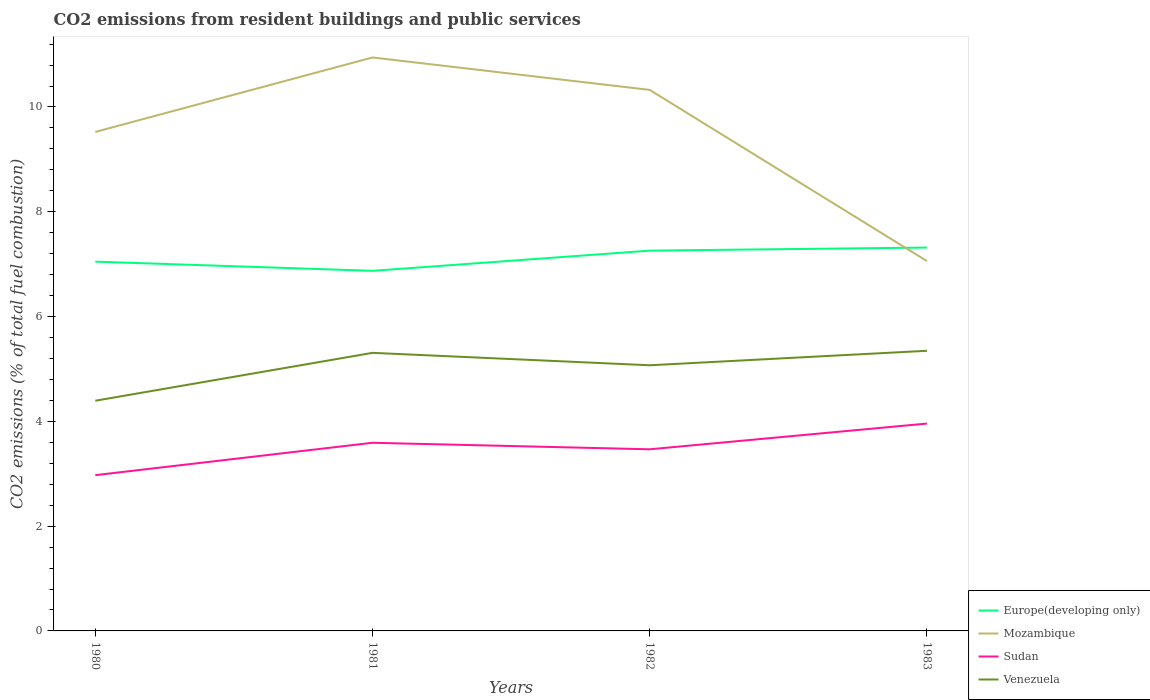Across all years, what is the maximum total CO2 emitted in Venezuela?
Give a very brief answer. 4.39. What is the total total CO2 emitted in Europe(developing only) in the graph?
Your response must be concise. -0.21. What is the difference between the highest and the second highest total CO2 emitted in Mozambique?
Provide a short and direct response. 3.89. Is the total CO2 emitted in Venezuela strictly greater than the total CO2 emitted in Sudan over the years?
Your answer should be compact. No. How many years are there in the graph?
Provide a succinct answer. 4. What is the difference between two consecutive major ticks on the Y-axis?
Provide a short and direct response. 2. Does the graph contain any zero values?
Your response must be concise. No. Where does the legend appear in the graph?
Offer a terse response. Bottom right. How many legend labels are there?
Offer a very short reply. 4. How are the legend labels stacked?
Keep it short and to the point. Vertical. What is the title of the graph?
Keep it short and to the point. CO2 emissions from resident buildings and public services. Does "Sierra Leone" appear as one of the legend labels in the graph?
Give a very brief answer. No. What is the label or title of the Y-axis?
Your answer should be very brief. CO2 emissions (% of total fuel combustion). What is the CO2 emissions (% of total fuel combustion) in Europe(developing only) in 1980?
Make the answer very short. 7.05. What is the CO2 emissions (% of total fuel combustion) of Mozambique in 1980?
Ensure brevity in your answer.  9.52. What is the CO2 emissions (% of total fuel combustion) of Sudan in 1980?
Offer a very short reply. 2.97. What is the CO2 emissions (% of total fuel combustion) of Venezuela in 1980?
Offer a terse response. 4.39. What is the CO2 emissions (% of total fuel combustion) of Europe(developing only) in 1981?
Offer a terse response. 6.87. What is the CO2 emissions (% of total fuel combustion) in Mozambique in 1981?
Give a very brief answer. 10.95. What is the CO2 emissions (% of total fuel combustion) in Sudan in 1981?
Provide a short and direct response. 3.59. What is the CO2 emissions (% of total fuel combustion) in Venezuela in 1981?
Offer a very short reply. 5.31. What is the CO2 emissions (% of total fuel combustion) of Europe(developing only) in 1982?
Provide a short and direct response. 7.26. What is the CO2 emissions (% of total fuel combustion) of Mozambique in 1982?
Your response must be concise. 10.33. What is the CO2 emissions (% of total fuel combustion) of Sudan in 1982?
Your response must be concise. 3.47. What is the CO2 emissions (% of total fuel combustion) of Venezuela in 1982?
Offer a very short reply. 5.07. What is the CO2 emissions (% of total fuel combustion) in Europe(developing only) in 1983?
Your answer should be compact. 7.32. What is the CO2 emissions (% of total fuel combustion) in Mozambique in 1983?
Provide a succinct answer. 7.06. What is the CO2 emissions (% of total fuel combustion) of Sudan in 1983?
Your response must be concise. 3.96. What is the CO2 emissions (% of total fuel combustion) in Venezuela in 1983?
Offer a terse response. 5.35. Across all years, what is the maximum CO2 emissions (% of total fuel combustion) in Europe(developing only)?
Keep it short and to the point. 7.32. Across all years, what is the maximum CO2 emissions (% of total fuel combustion) of Mozambique?
Give a very brief answer. 10.95. Across all years, what is the maximum CO2 emissions (% of total fuel combustion) of Sudan?
Give a very brief answer. 3.96. Across all years, what is the maximum CO2 emissions (% of total fuel combustion) of Venezuela?
Give a very brief answer. 5.35. Across all years, what is the minimum CO2 emissions (% of total fuel combustion) of Europe(developing only)?
Keep it short and to the point. 6.87. Across all years, what is the minimum CO2 emissions (% of total fuel combustion) in Mozambique?
Your response must be concise. 7.06. Across all years, what is the minimum CO2 emissions (% of total fuel combustion) in Sudan?
Offer a very short reply. 2.97. Across all years, what is the minimum CO2 emissions (% of total fuel combustion) in Venezuela?
Your answer should be compact. 4.39. What is the total CO2 emissions (% of total fuel combustion) of Europe(developing only) in the graph?
Provide a succinct answer. 28.5. What is the total CO2 emissions (% of total fuel combustion) of Mozambique in the graph?
Your answer should be very brief. 37.85. What is the total CO2 emissions (% of total fuel combustion) of Sudan in the graph?
Your answer should be compact. 13.99. What is the total CO2 emissions (% of total fuel combustion) in Venezuela in the graph?
Make the answer very short. 20.12. What is the difference between the CO2 emissions (% of total fuel combustion) in Europe(developing only) in 1980 and that in 1981?
Offer a very short reply. 0.18. What is the difference between the CO2 emissions (% of total fuel combustion) in Mozambique in 1980 and that in 1981?
Ensure brevity in your answer.  -1.42. What is the difference between the CO2 emissions (% of total fuel combustion) in Sudan in 1980 and that in 1981?
Offer a terse response. -0.62. What is the difference between the CO2 emissions (% of total fuel combustion) of Venezuela in 1980 and that in 1981?
Ensure brevity in your answer.  -0.91. What is the difference between the CO2 emissions (% of total fuel combustion) of Europe(developing only) in 1980 and that in 1982?
Your answer should be compact. -0.21. What is the difference between the CO2 emissions (% of total fuel combustion) in Mozambique in 1980 and that in 1982?
Provide a succinct answer. -0.8. What is the difference between the CO2 emissions (% of total fuel combustion) of Sudan in 1980 and that in 1982?
Make the answer very short. -0.49. What is the difference between the CO2 emissions (% of total fuel combustion) in Venezuela in 1980 and that in 1982?
Ensure brevity in your answer.  -0.68. What is the difference between the CO2 emissions (% of total fuel combustion) in Europe(developing only) in 1980 and that in 1983?
Your answer should be very brief. -0.27. What is the difference between the CO2 emissions (% of total fuel combustion) of Mozambique in 1980 and that in 1983?
Keep it short and to the point. 2.46. What is the difference between the CO2 emissions (% of total fuel combustion) in Sudan in 1980 and that in 1983?
Your answer should be very brief. -0.98. What is the difference between the CO2 emissions (% of total fuel combustion) in Venezuela in 1980 and that in 1983?
Provide a succinct answer. -0.95. What is the difference between the CO2 emissions (% of total fuel combustion) of Europe(developing only) in 1981 and that in 1982?
Provide a succinct answer. -0.39. What is the difference between the CO2 emissions (% of total fuel combustion) in Mozambique in 1981 and that in 1982?
Your answer should be compact. 0.62. What is the difference between the CO2 emissions (% of total fuel combustion) of Sudan in 1981 and that in 1982?
Give a very brief answer. 0.12. What is the difference between the CO2 emissions (% of total fuel combustion) of Venezuela in 1981 and that in 1982?
Your response must be concise. 0.24. What is the difference between the CO2 emissions (% of total fuel combustion) of Europe(developing only) in 1981 and that in 1983?
Keep it short and to the point. -0.44. What is the difference between the CO2 emissions (% of total fuel combustion) in Mozambique in 1981 and that in 1983?
Provide a short and direct response. 3.89. What is the difference between the CO2 emissions (% of total fuel combustion) of Sudan in 1981 and that in 1983?
Provide a succinct answer. -0.37. What is the difference between the CO2 emissions (% of total fuel combustion) of Venezuela in 1981 and that in 1983?
Provide a short and direct response. -0.04. What is the difference between the CO2 emissions (% of total fuel combustion) in Europe(developing only) in 1982 and that in 1983?
Provide a succinct answer. -0.06. What is the difference between the CO2 emissions (% of total fuel combustion) in Mozambique in 1982 and that in 1983?
Your answer should be very brief. 3.27. What is the difference between the CO2 emissions (% of total fuel combustion) in Sudan in 1982 and that in 1983?
Offer a very short reply. -0.49. What is the difference between the CO2 emissions (% of total fuel combustion) of Venezuela in 1982 and that in 1983?
Provide a succinct answer. -0.28. What is the difference between the CO2 emissions (% of total fuel combustion) in Europe(developing only) in 1980 and the CO2 emissions (% of total fuel combustion) in Mozambique in 1981?
Give a very brief answer. -3.9. What is the difference between the CO2 emissions (% of total fuel combustion) in Europe(developing only) in 1980 and the CO2 emissions (% of total fuel combustion) in Sudan in 1981?
Give a very brief answer. 3.46. What is the difference between the CO2 emissions (% of total fuel combustion) of Europe(developing only) in 1980 and the CO2 emissions (% of total fuel combustion) of Venezuela in 1981?
Your response must be concise. 1.74. What is the difference between the CO2 emissions (% of total fuel combustion) in Mozambique in 1980 and the CO2 emissions (% of total fuel combustion) in Sudan in 1981?
Ensure brevity in your answer.  5.93. What is the difference between the CO2 emissions (% of total fuel combustion) in Mozambique in 1980 and the CO2 emissions (% of total fuel combustion) in Venezuela in 1981?
Make the answer very short. 4.22. What is the difference between the CO2 emissions (% of total fuel combustion) in Sudan in 1980 and the CO2 emissions (% of total fuel combustion) in Venezuela in 1981?
Offer a very short reply. -2.33. What is the difference between the CO2 emissions (% of total fuel combustion) of Europe(developing only) in 1980 and the CO2 emissions (% of total fuel combustion) of Mozambique in 1982?
Ensure brevity in your answer.  -3.28. What is the difference between the CO2 emissions (% of total fuel combustion) of Europe(developing only) in 1980 and the CO2 emissions (% of total fuel combustion) of Sudan in 1982?
Your answer should be very brief. 3.58. What is the difference between the CO2 emissions (% of total fuel combustion) of Europe(developing only) in 1980 and the CO2 emissions (% of total fuel combustion) of Venezuela in 1982?
Your answer should be compact. 1.98. What is the difference between the CO2 emissions (% of total fuel combustion) of Mozambique in 1980 and the CO2 emissions (% of total fuel combustion) of Sudan in 1982?
Make the answer very short. 6.06. What is the difference between the CO2 emissions (% of total fuel combustion) in Mozambique in 1980 and the CO2 emissions (% of total fuel combustion) in Venezuela in 1982?
Offer a very short reply. 4.45. What is the difference between the CO2 emissions (% of total fuel combustion) in Sudan in 1980 and the CO2 emissions (% of total fuel combustion) in Venezuela in 1982?
Offer a terse response. -2.1. What is the difference between the CO2 emissions (% of total fuel combustion) in Europe(developing only) in 1980 and the CO2 emissions (% of total fuel combustion) in Mozambique in 1983?
Offer a very short reply. -0.01. What is the difference between the CO2 emissions (% of total fuel combustion) in Europe(developing only) in 1980 and the CO2 emissions (% of total fuel combustion) in Sudan in 1983?
Give a very brief answer. 3.09. What is the difference between the CO2 emissions (% of total fuel combustion) in Europe(developing only) in 1980 and the CO2 emissions (% of total fuel combustion) in Venezuela in 1983?
Your answer should be compact. 1.7. What is the difference between the CO2 emissions (% of total fuel combustion) of Mozambique in 1980 and the CO2 emissions (% of total fuel combustion) of Sudan in 1983?
Provide a succinct answer. 5.57. What is the difference between the CO2 emissions (% of total fuel combustion) in Mozambique in 1980 and the CO2 emissions (% of total fuel combustion) in Venezuela in 1983?
Ensure brevity in your answer.  4.18. What is the difference between the CO2 emissions (% of total fuel combustion) in Sudan in 1980 and the CO2 emissions (% of total fuel combustion) in Venezuela in 1983?
Make the answer very short. -2.37. What is the difference between the CO2 emissions (% of total fuel combustion) of Europe(developing only) in 1981 and the CO2 emissions (% of total fuel combustion) of Mozambique in 1982?
Offer a terse response. -3.45. What is the difference between the CO2 emissions (% of total fuel combustion) in Europe(developing only) in 1981 and the CO2 emissions (% of total fuel combustion) in Sudan in 1982?
Your answer should be very brief. 3.41. What is the difference between the CO2 emissions (% of total fuel combustion) in Europe(developing only) in 1981 and the CO2 emissions (% of total fuel combustion) in Venezuela in 1982?
Provide a short and direct response. 1.8. What is the difference between the CO2 emissions (% of total fuel combustion) of Mozambique in 1981 and the CO2 emissions (% of total fuel combustion) of Sudan in 1982?
Offer a terse response. 7.48. What is the difference between the CO2 emissions (% of total fuel combustion) in Mozambique in 1981 and the CO2 emissions (% of total fuel combustion) in Venezuela in 1982?
Offer a terse response. 5.87. What is the difference between the CO2 emissions (% of total fuel combustion) in Sudan in 1981 and the CO2 emissions (% of total fuel combustion) in Venezuela in 1982?
Make the answer very short. -1.48. What is the difference between the CO2 emissions (% of total fuel combustion) in Europe(developing only) in 1981 and the CO2 emissions (% of total fuel combustion) in Mozambique in 1983?
Provide a succinct answer. -0.19. What is the difference between the CO2 emissions (% of total fuel combustion) of Europe(developing only) in 1981 and the CO2 emissions (% of total fuel combustion) of Sudan in 1983?
Ensure brevity in your answer.  2.91. What is the difference between the CO2 emissions (% of total fuel combustion) of Europe(developing only) in 1981 and the CO2 emissions (% of total fuel combustion) of Venezuela in 1983?
Ensure brevity in your answer.  1.53. What is the difference between the CO2 emissions (% of total fuel combustion) of Mozambique in 1981 and the CO2 emissions (% of total fuel combustion) of Sudan in 1983?
Your answer should be compact. 6.99. What is the difference between the CO2 emissions (% of total fuel combustion) in Mozambique in 1981 and the CO2 emissions (% of total fuel combustion) in Venezuela in 1983?
Your answer should be compact. 5.6. What is the difference between the CO2 emissions (% of total fuel combustion) of Sudan in 1981 and the CO2 emissions (% of total fuel combustion) of Venezuela in 1983?
Make the answer very short. -1.76. What is the difference between the CO2 emissions (% of total fuel combustion) in Europe(developing only) in 1982 and the CO2 emissions (% of total fuel combustion) in Mozambique in 1983?
Your answer should be compact. 0.2. What is the difference between the CO2 emissions (% of total fuel combustion) of Europe(developing only) in 1982 and the CO2 emissions (% of total fuel combustion) of Sudan in 1983?
Keep it short and to the point. 3.3. What is the difference between the CO2 emissions (% of total fuel combustion) of Europe(developing only) in 1982 and the CO2 emissions (% of total fuel combustion) of Venezuela in 1983?
Make the answer very short. 1.91. What is the difference between the CO2 emissions (% of total fuel combustion) of Mozambique in 1982 and the CO2 emissions (% of total fuel combustion) of Sudan in 1983?
Your answer should be very brief. 6.37. What is the difference between the CO2 emissions (% of total fuel combustion) of Mozambique in 1982 and the CO2 emissions (% of total fuel combustion) of Venezuela in 1983?
Provide a succinct answer. 4.98. What is the difference between the CO2 emissions (% of total fuel combustion) of Sudan in 1982 and the CO2 emissions (% of total fuel combustion) of Venezuela in 1983?
Your answer should be very brief. -1.88. What is the average CO2 emissions (% of total fuel combustion) in Europe(developing only) per year?
Offer a terse response. 7.12. What is the average CO2 emissions (% of total fuel combustion) in Mozambique per year?
Keep it short and to the point. 9.46. What is the average CO2 emissions (% of total fuel combustion) of Sudan per year?
Your answer should be very brief. 3.5. What is the average CO2 emissions (% of total fuel combustion) of Venezuela per year?
Give a very brief answer. 5.03. In the year 1980, what is the difference between the CO2 emissions (% of total fuel combustion) of Europe(developing only) and CO2 emissions (% of total fuel combustion) of Mozambique?
Ensure brevity in your answer.  -2.48. In the year 1980, what is the difference between the CO2 emissions (% of total fuel combustion) in Europe(developing only) and CO2 emissions (% of total fuel combustion) in Sudan?
Offer a very short reply. 4.08. In the year 1980, what is the difference between the CO2 emissions (% of total fuel combustion) of Europe(developing only) and CO2 emissions (% of total fuel combustion) of Venezuela?
Offer a very short reply. 2.65. In the year 1980, what is the difference between the CO2 emissions (% of total fuel combustion) of Mozambique and CO2 emissions (% of total fuel combustion) of Sudan?
Your answer should be compact. 6.55. In the year 1980, what is the difference between the CO2 emissions (% of total fuel combustion) of Mozambique and CO2 emissions (% of total fuel combustion) of Venezuela?
Provide a short and direct response. 5.13. In the year 1980, what is the difference between the CO2 emissions (% of total fuel combustion) of Sudan and CO2 emissions (% of total fuel combustion) of Venezuela?
Your answer should be compact. -1.42. In the year 1981, what is the difference between the CO2 emissions (% of total fuel combustion) in Europe(developing only) and CO2 emissions (% of total fuel combustion) in Mozambique?
Give a very brief answer. -4.07. In the year 1981, what is the difference between the CO2 emissions (% of total fuel combustion) in Europe(developing only) and CO2 emissions (% of total fuel combustion) in Sudan?
Make the answer very short. 3.28. In the year 1981, what is the difference between the CO2 emissions (% of total fuel combustion) in Europe(developing only) and CO2 emissions (% of total fuel combustion) in Venezuela?
Your response must be concise. 1.57. In the year 1981, what is the difference between the CO2 emissions (% of total fuel combustion) in Mozambique and CO2 emissions (% of total fuel combustion) in Sudan?
Your response must be concise. 7.35. In the year 1981, what is the difference between the CO2 emissions (% of total fuel combustion) of Mozambique and CO2 emissions (% of total fuel combustion) of Venezuela?
Your answer should be compact. 5.64. In the year 1981, what is the difference between the CO2 emissions (% of total fuel combustion) of Sudan and CO2 emissions (% of total fuel combustion) of Venezuela?
Provide a short and direct response. -1.72. In the year 1982, what is the difference between the CO2 emissions (% of total fuel combustion) in Europe(developing only) and CO2 emissions (% of total fuel combustion) in Mozambique?
Give a very brief answer. -3.07. In the year 1982, what is the difference between the CO2 emissions (% of total fuel combustion) of Europe(developing only) and CO2 emissions (% of total fuel combustion) of Sudan?
Offer a terse response. 3.79. In the year 1982, what is the difference between the CO2 emissions (% of total fuel combustion) in Europe(developing only) and CO2 emissions (% of total fuel combustion) in Venezuela?
Provide a short and direct response. 2.19. In the year 1982, what is the difference between the CO2 emissions (% of total fuel combustion) of Mozambique and CO2 emissions (% of total fuel combustion) of Sudan?
Your answer should be compact. 6.86. In the year 1982, what is the difference between the CO2 emissions (% of total fuel combustion) in Mozambique and CO2 emissions (% of total fuel combustion) in Venezuela?
Give a very brief answer. 5.26. In the year 1982, what is the difference between the CO2 emissions (% of total fuel combustion) of Sudan and CO2 emissions (% of total fuel combustion) of Venezuela?
Give a very brief answer. -1.6. In the year 1983, what is the difference between the CO2 emissions (% of total fuel combustion) in Europe(developing only) and CO2 emissions (% of total fuel combustion) in Mozambique?
Provide a succinct answer. 0.26. In the year 1983, what is the difference between the CO2 emissions (% of total fuel combustion) of Europe(developing only) and CO2 emissions (% of total fuel combustion) of Sudan?
Make the answer very short. 3.36. In the year 1983, what is the difference between the CO2 emissions (% of total fuel combustion) in Europe(developing only) and CO2 emissions (% of total fuel combustion) in Venezuela?
Provide a short and direct response. 1.97. In the year 1983, what is the difference between the CO2 emissions (% of total fuel combustion) of Mozambique and CO2 emissions (% of total fuel combustion) of Sudan?
Provide a succinct answer. 3.1. In the year 1983, what is the difference between the CO2 emissions (% of total fuel combustion) of Mozambique and CO2 emissions (% of total fuel combustion) of Venezuela?
Provide a succinct answer. 1.71. In the year 1983, what is the difference between the CO2 emissions (% of total fuel combustion) of Sudan and CO2 emissions (% of total fuel combustion) of Venezuela?
Provide a short and direct response. -1.39. What is the ratio of the CO2 emissions (% of total fuel combustion) in Europe(developing only) in 1980 to that in 1981?
Offer a very short reply. 1.03. What is the ratio of the CO2 emissions (% of total fuel combustion) in Mozambique in 1980 to that in 1981?
Make the answer very short. 0.87. What is the ratio of the CO2 emissions (% of total fuel combustion) of Sudan in 1980 to that in 1981?
Give a very brief answer. 0.83. What is the ratio of the CO2 emissions (% of total fuel combustion) in Venezuela in 1980 to that in 1981?
Offer a very short reply. 0.83. What is the ratio of the CO2 emissions (% of total fuel combustion) of Europe(developing only) in 1980 to that in 1982?
Ensure brevity in your answer.  0.97. What is the ratio of the CO2 emissions (% of total fuel combustion) of Mozambique in 1980 to that in 1982?
Give a very brief answer. 0.92. What is the ratio of the CO2 emissions (% of total fuel combustion) of Sudan in 1980 to that in 1982?
Make the answer very short. 0.86. What is the ratio of the CO2 emissions (% of total fuel combustion) in Venezuela in 1980 to that in 1982?
Give a very brief answer. 0.87. What is the ratio of the CO2 emissions (% of total fuel combustion) of Europe(developing only) in 1980 to that in 1983?
Ensure brevity in your answer.  0.96. What is the ratio of the CO2 emissions (% of total fuel combustion) in Mozambique in 1980 to that in 1983?
Make the answer very short. 1.35. What is the ratio of the CO2 emissions (% of total fuel combustion) in Sudan in 1980 to that in 1983?
Provide a short and direct response. 0.75. What is the ratio of the CO2 emissions (% of total fuel combustion) of Venezuela in 1980 to that in 1983?
Your answer should be compact. 0.82. What is the ratio of the CO2 emissions (% of total fuel combustion) of Europe(developing only) in 1981 to that in 1982?
Keep it short and to the point. 0.95. What is the ratio of the CO2 emissions (% of total fuel combustion) of Mozambique in 1981 to that in 1982?
Keep it short and to the point. 1.06. What is the ratio of the CO2 emissions (% of total fuel combustion) of Sudan in 1981 to that in 1982?
Your answer should be very brief. 1.04. What is the ratio of the CO2 emissions (% of total fuel combustion) of Venezuela in 1981 to that in 1982?
Make the answer very short. 1.05. What is the ratio of the CO2 emissions (% of total fuel combustion) of Europe(developing only) in 1981 to that in 1983?
Provide a succinct answer. 0.94. What is the ratio of the CO2 emissions (% of total fuel combustion) in Mozambique in 1981 to that in 1983?
Give a very brief answer. 1.55. What is the ratio of the CO2 emissions (% of total fuel combustion) in Sudan in 1981 to that in 1983?
Your answer should be very brief. 0.91. What is the ratio of the CO2 emissions (% of total fuel combustion) of Venezuela in 1981 to that in 1983?
Ensure brevity in your answer.  0.99. What is the ratio of the CO2 emissions (% of total fuel combustion) of Mozambique in 1982 to that in 1983?
Your response must be concise. 1.46. What is the ratio of the CO2 emissions (% of total fuel combustion) of Sudan in 1982 to that in 1983?
Provide a short and direct response. 0.88. What is the ratio of the CO2 emissions (% of total fuel combustion) in Venezuela in 1982 to that in 1983?
Your response must be concise. 0.95. What is the difference between the highest and the second highest CO2 emissions (% of total fuel combustion) of Europe(developing only)?
Keep it short and to the point. 0.06. What is the difference between the highest and the second highest CO2 emissions (% of total fuel combustion) of Mozambique?
Your answer should be compact. 0.62. What is the difference between the highest and the second highest CO2 emissions (% of total fuel combustion) in Sudan?
Offer a terse response. 0.37. What is the difference between the highest and the second highest CO2 emissions (% of total fuel combustion) of Venezuela?
Make the answer very short. 0.04. What is the difference between the highest and the lowest CO2 emissions (% of total fuel combustion) in Europe(developing only)?
Make the answer very short. 0.44. What is the difference between the highest and the lowest CO2 emissions (% of total fuel combustion) of Mozambique?
Your answer should be compact. 3.89. What is the difference between the highest and the lowest CO2 emissions (% of total fuel combustion) of Venezuela?
Your answer should be compact. 0.95. 